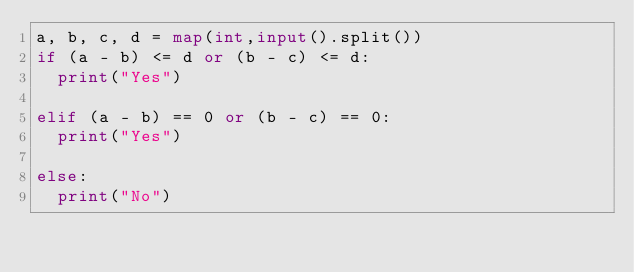Convert code to text. <code><loc_0><loc_0><loc_500><loc_500><_Python_>a, b, c, d = map(int,input().split())
if (a - b) <= d or (b - c) <= d:
  print("Yes")

elif (a - b) == 0 or (b - c) == 0:
  print("Yes")
  
else:
  print("No")
</code> 